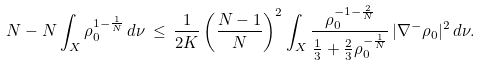<formula> <loc_0><loc_0><loc_500><loc_500>N - N \int _ { X } \rho _ { 0 } ^ { 1 - \frac { 1 } { N } } \, d \nu \, \leq \, \frac { 1 } { 2 K } \left ( \frac { N - 1 } { N } \right ) ^ { 2 } \int _ { X } \frac { \rho _ { 0 } ^ { - 1 - \frac { 2 } { N } } } { \frac { 1 } { 3 } + \frac { 2 } { 3 } \rho _ { 0 } ^ { - \frac { 1 } { N } } } \, | \nabla ^ { - } \rho _ { 0 } | ^ { 2 } \, d \nu .</formula> 